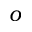Convert formula to latex. <formula><loc_0><loc_0><loc_500><loc_500>o</formula> 